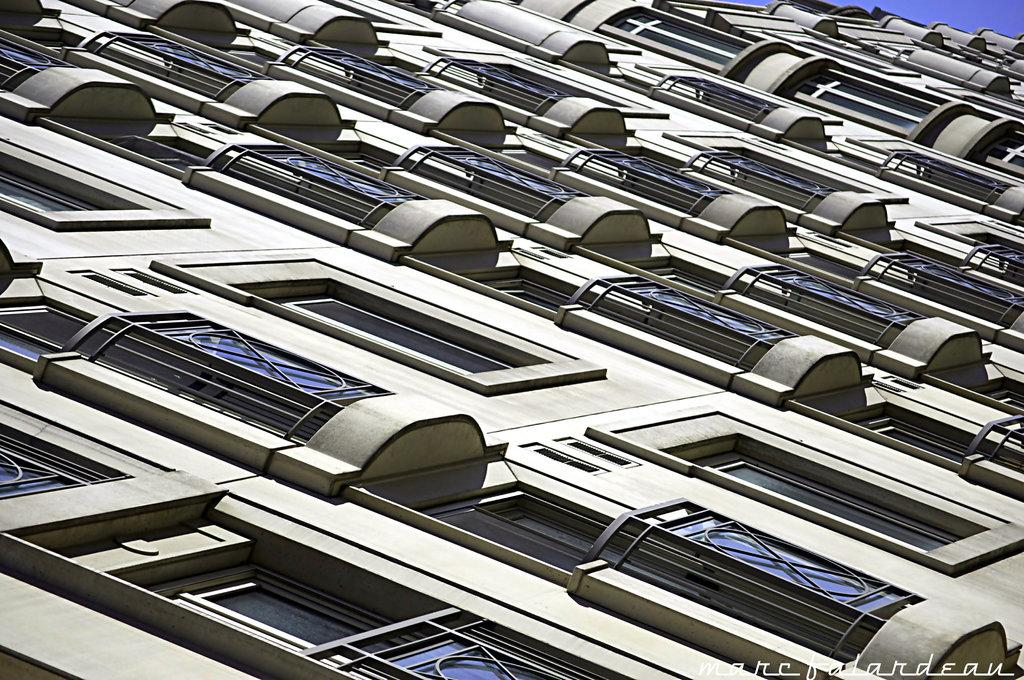What is the main structure in the image? There is a building in the image. What feature can be seen on the building? The building has windows. What is visible in the background of the image? The sky is visible in the image. How many pears are hanging from the windows of the building in the image? There are no pears visible in the image, as it only features a building with windows and the sky in the background. 